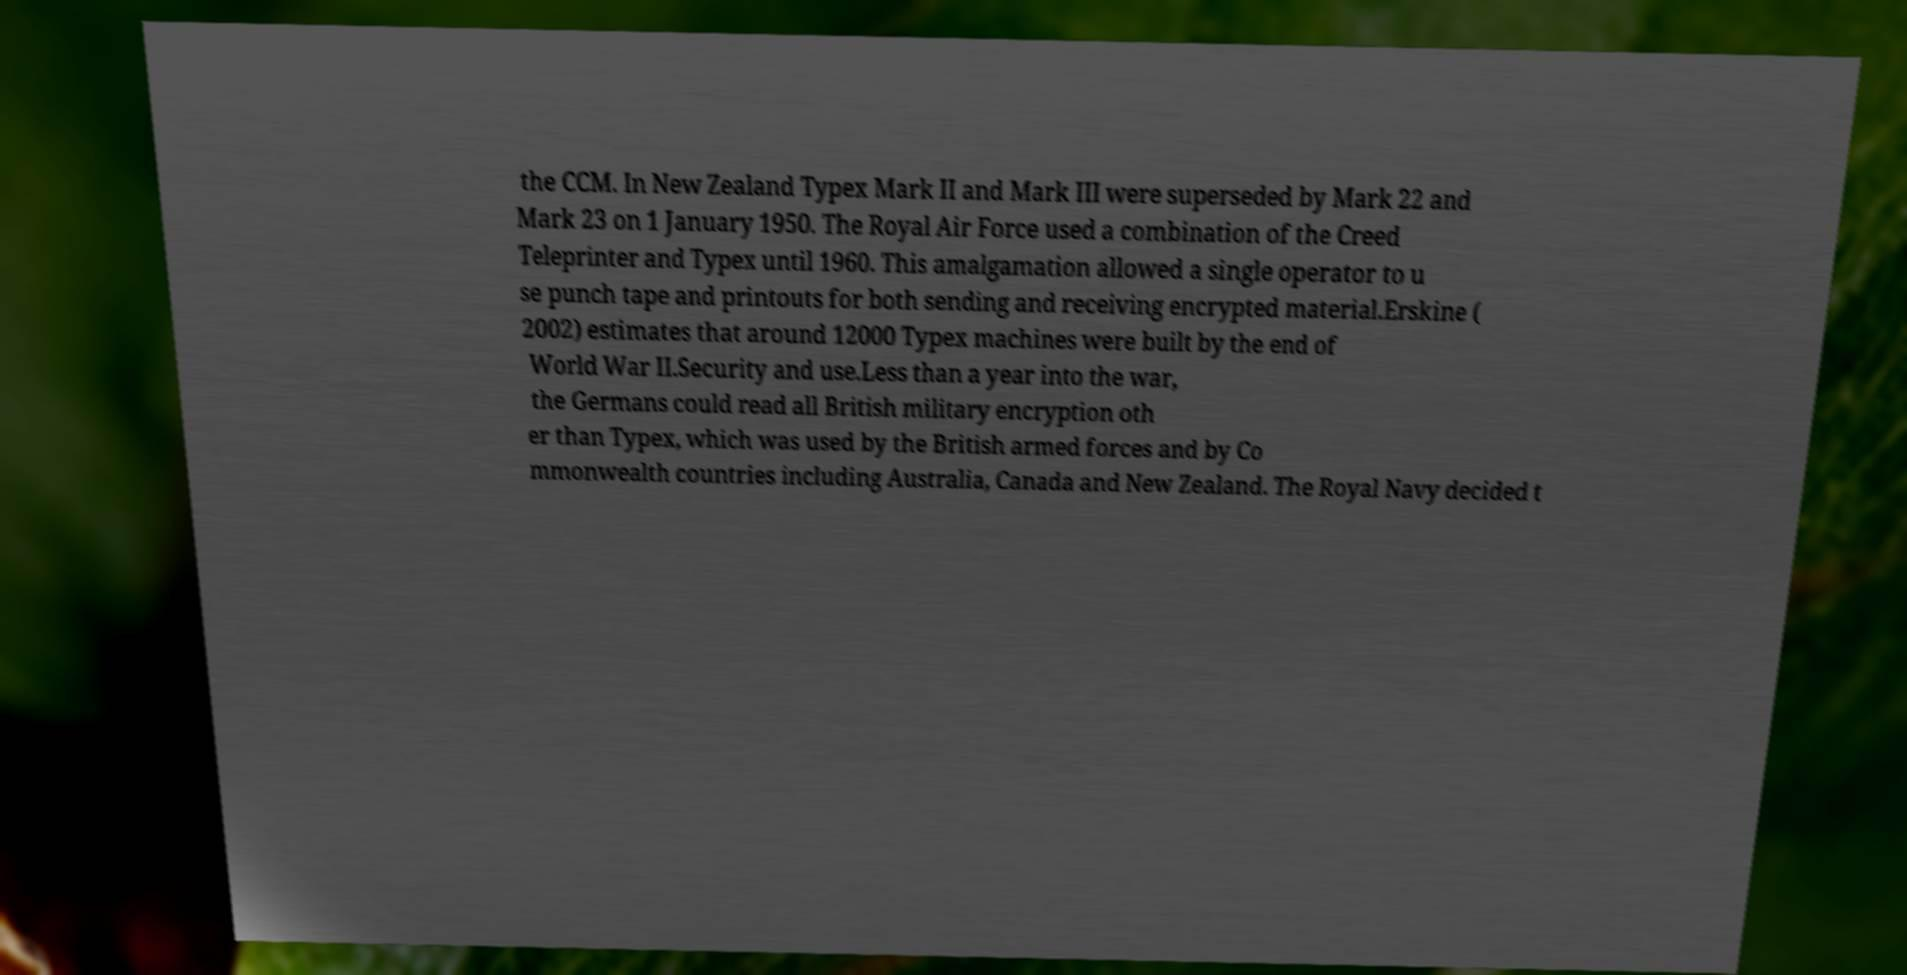There's text embedded in this image that I need extracted. Can you transcribe it verbatim? the CCM. In New Zealand Typex Mark II and Mark III were superseded by Mark 22 and Mark 23 on 1 January 1950. The Royal Air Force used a combination of the Creed Teleprinter and Typex until 1960. This amalgamation allowed a single operator to u se punch tape and printouts for both sending and receiving encrypted material.Erskine ( 2002) estimates that around 12000 Typex machines were built by the end of World War II.Security and use.Less than a year into the war, the Germans could read all British military encryption oth er than Typex, which was used by the British armed forces and by Co mmonwealth countries including Australia, Canada and New Zealand. The Royal Navy decided t 